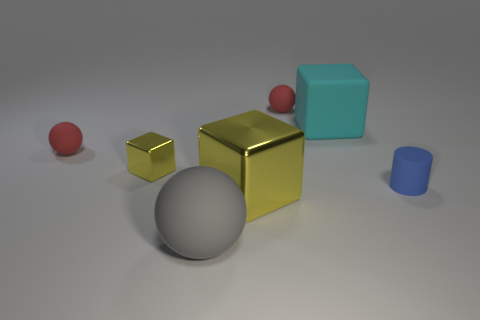What number of cyan objects have the same material as the blue cylinder?
Ensure brevity in your answer.  1. There is a big metal object that is the same color as the small shiny thing; what is its shape?
Ensure brevity in your answer.  Cube. What is the shape of the matte thing that is the same size as the cyan matte cube?
Provide a short and direct response. Sphere. There is another object that is the same color as the large shiny object; what material is it?
Your answer should be compact. Metal. Are there any cyan rubber objects behind the gray rubber ball?
Provide a short and direct response. Yes. Is there a small yellow metal object of the same shape as the big yellow object?
Your answer should be very brief. Yes. Does the yellow thing that is in front of the blue thing have the same shape as the small red object to the right of the large gray sphere?
Make the answer very short. No. Is there a metallic object that has the same size as the gray matte ball?
Your response must be concise. Yes. Are there the same number of red matte balls that are to the left of the rubber cube and cubes to the right of the small yellow thing?
Keep it short and to the point. Yes. Are the red sphere that is on the right side of the tiny yellow thing and the yellow object that is left of the big yellow object made of the same material?
Your answer should be compact. No. 